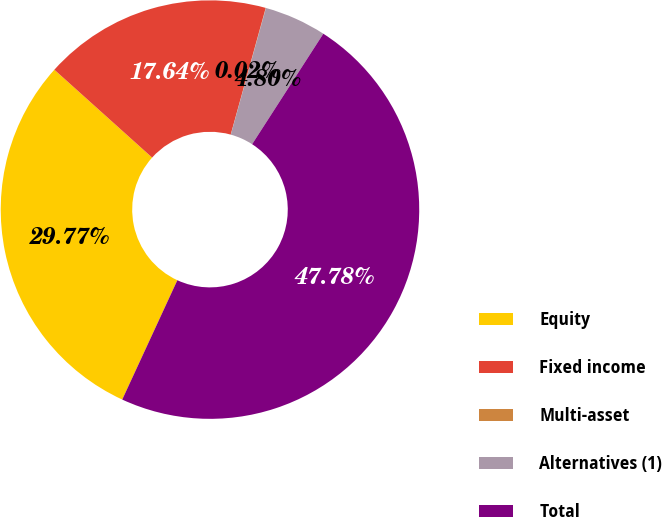Convert chart. <chart><loc_0><loc_0><loc_500><loc_500><pie_chart><fcel>Equity<fcel>Fixed income<fcel>Multi-asset<fcel>Alternatives (1)<fcel>Total<nl><fcel>29.77%<fcel>17.64%<fcel>0.02%<fcel>4.8%<fcel>47.78%<nl></chart> 